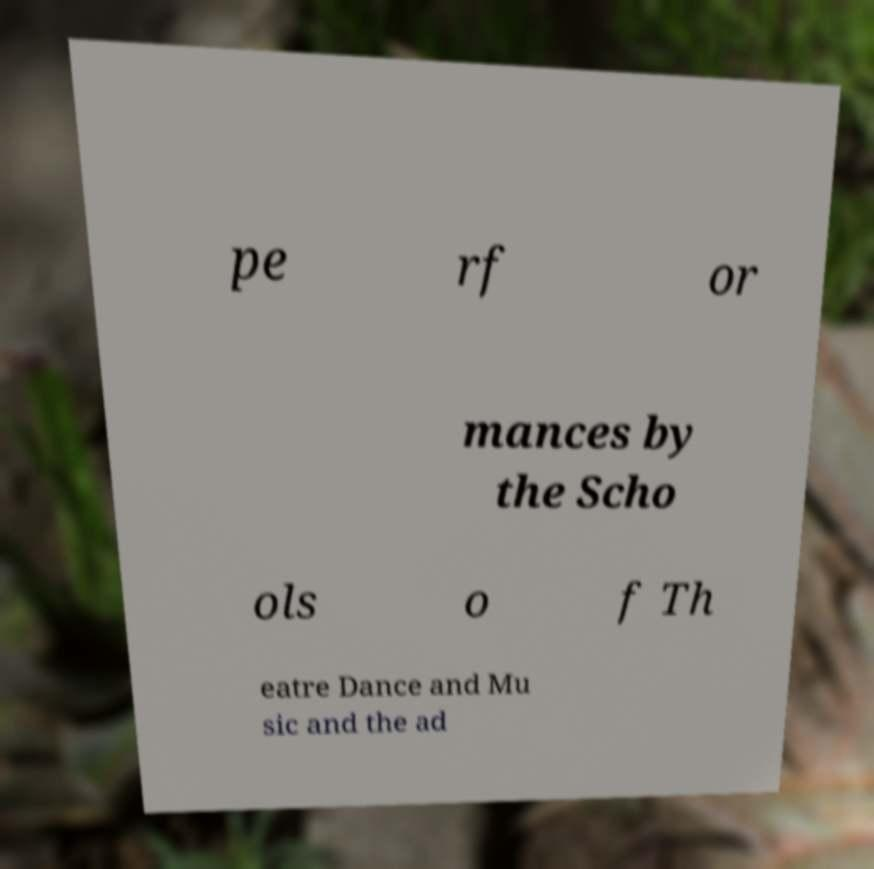Could you assist in decoding the text presented in this image and type it out clearly? pe rf or mances by the Scho ols o f Th eatre Dance and Mu sic and the ad 